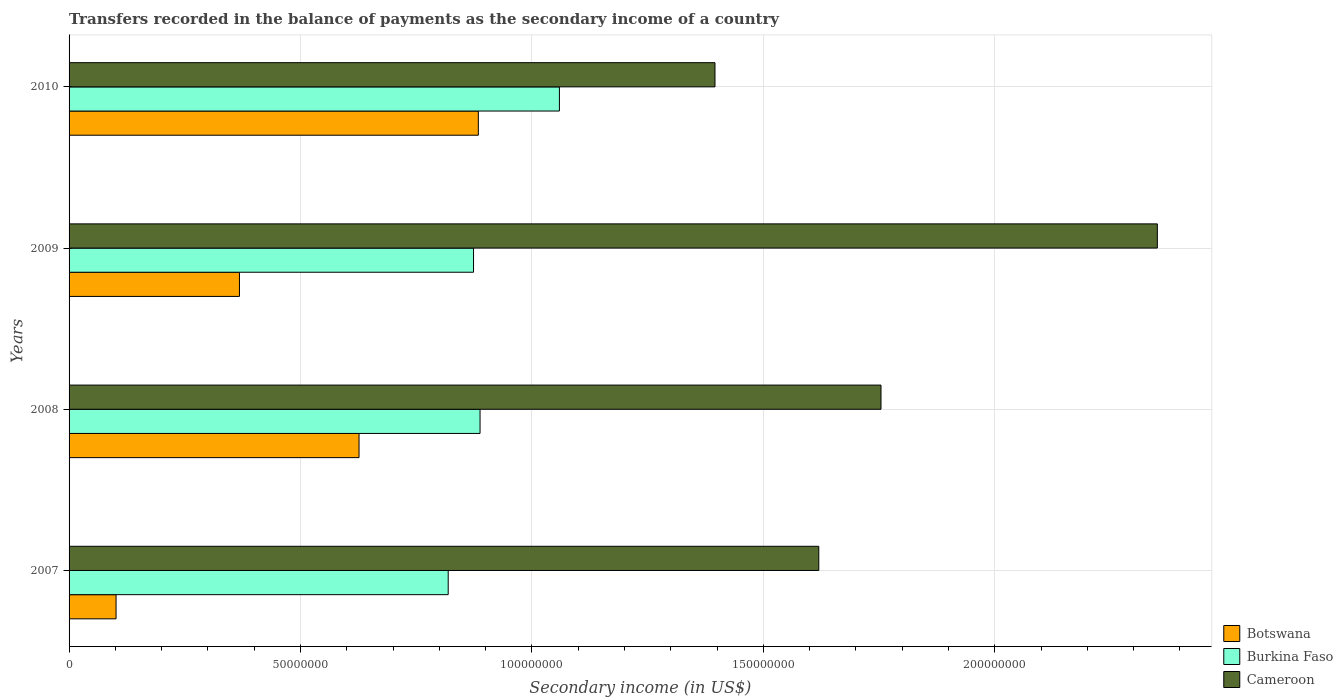Are the number of bars per tick equal to the number of legend labels?
Offer a terse response. Yes. How many bars are there on the 1st tick from the top?
Offer a very short reply. 3. How many bars are there on the 1st tick from the bottom?
Your answer should be compact. 3. What is the secondary income of in Botswana in 2009?
Ensure brevity in your answer.  3.68e+07. Across all years, what is the maximum secondary income of in Burkina Faso?
Ensure brevity in your answer.  1.06e+08. Across all years, what is the minimum secondary income of in Cameroon?
Your answer should be compact. 1.40e+08. In which year was the secondary income of in Cameroon minimum?
Your answer should be very brief. 2010. What is the total secondary income of in Burkina Faso in the graph?
Provide a short and direct response. 3.64e+08. What is the difference between the secondary income of in Botswana in 2008 and that in 2009?
Provide a short and direct response. 2.58e+07. What is the difference between the secondary income of in Botswana in 2010 and the secondary income of in Cameroon in 2007?
Make the answer very short. -7.36e+07. What is the average secondary income of in Botswana per year?
Provide a succinct answer. 4.95e+07. In the year 2008, what is the difference between the secondary income of in Burkina Faso and secondary income of in Botswana?
Offer a terse response. 2.61e+07. What is the ratio of the secondary income of in Botswana in 2007 to that in 2008?
Ensure brevity in your answer.  0.16. Is the difference between the secondary income of in Burkina Faso in 2007 and 2010 greater than the difference between the secondary income of in Botswana in 2007 and 2010?
Keep it short and to the point. Yes. What is the difference between the highest and the second highest secondary income of in Cameroon?
Provide a short and direct response. 5.97e+07. What is the difference between the highest and the lowest secondary income of in Botswana?
Ensure brevity in your answer.  7.83e+07. In how many years, is the secondary income of in Burkina Faso greater than the average secondary income of in Burkina Faso taken over all years?
Offer a terse response. 1. What does the 2nd bar from the top in 2008 represents?
Your response must be concise. Burkina Faso. What does the 2nd bar from the bottom in 2007 represents?
Your answer should be very brief. Burkina Faso. How many bars are there?
Give a very brief answer. 12. Are all the bars in the graph horizontal?
Give a very brief answer. Yes. How many years are there in the graph?
Ensure brevity in your answer.  4. What is the difference between two consecutive major ticks on the X-axis?
Provide a succinct answer. 5.00e+07. Are the values on the major ticks of X-axis written in scientific E-notation?
Offer a terse response. No. Does the graph contain any zero values?
Provide a short and direct response. No. Does the graph contain grids?
Offer a terse response. Yes. Where does the legend appear in the graph?
Ensure brevity in your answer.  Bottom right. What is the title of the graph?
Make the answer very short. Transfers recorded in the balance of payments as the secondary income of a country. What is the label or title of the X-axis?
Your answer should be very brief. Secondary income (in US$). What is the label or title of the Y-axis?
Offer a very short reply. Years. What is the Secondary income (in US$) of Botswana in 2007?
Keep it short and to the point. 1.02e+07. What is the Secondary income (in US$) of Burkina Faso in 2007?
Keep it short and to the point. 8.19e+07. What is the Secondary income (in US$) in Cameroon in 2007?
Your response must be concise. 1.62e+08. What is the Secondary income (in US$) of Botswana in 2008?
Give a very brief answer. 6.26e+07. What is the Secondary income (in US$) in Burkina Faso in 2008?
Your answer should be very brief. 8.88e+07. What is the Secondary income (in US$) of Cameroon in 2008?
Ensure brevity in your answer.  1.75e+08. What is the Secondary income (in US$) in Botswana in 2009?
Your response must be concise. 3.68e+07. What is the Secondary income (in US$) in Burkina Faso in 2009?
Offer a very short reply. 8.74e+07. What is the Secondary income (in US$) in Cameroon in 2009?
Your answer should be compact. 2.35e+08. What is the Secondary income (in US$) in Botswana in 2010?
Give a very brief answer. 8.84e+07. What is the Secondary income (in US$) of Burkina Faso in 2010?
Ensure brevity in your answer.  1.06e+08. What is the Secondary income (in US$) of Cameroon in 2010?
Offer a very short reply. 1.40e+08. Across all years, what is the maximum Secondary income (in US$) in Botswana?
Provide a succinct answer. 8.84e+07. Across all years, what is the maximum Secondary income (in US$) in Burkina Faso?
Offer a very short reply. 1.06e+08. Across all years, what is the maximum Secondary income (in US$) of Cameroon?
Make the answer very short. 2.35e+08. Across all years, what is the minimum Secondary income (in US$) of Botswana?
Your response must be concise. 1.02e+07. Across all years, what is the minimum Secondary income (in US$) of Burkina Faso?
Give a very brief answer. 8.19e+07. Across all years, what is the minimum Secondary income (in US$) in Cameroon?
Ensure brevity in your answer.  1.40e+08. What is the total Secondary income (in US$) of Botswana in the graph?
Offer a terse response. 1.98e+08. What is the total Secondary income (in US$) in Burkina Faso in the graph?
Provide a short and direct response. 3.64e+08. What is the total Secondary income (in US$) of Cameroon in the graph?
Make the answer very short. 7.12e+08. What is the difference between the Secondary income (in US$) in Botswana in 2007 and that in 2008?
Your answer should be very brief. -5.25e+07. What is the difference between the Secondary income (in US$) of Burkina Faso in 2007 and that in 2008?
Offer a terse response. -6.88e+06. What is the difference between the Secondary income (in US$) of Cameroon in 2007 and that in 2008?
Your answer should be very brief. -1.34e+07. What is the difference between the Secondary income (in US$) in Botswana in 2007 and that in 2009?
Your answer should be very brief. -2.67e+07. What is the difference between the Secondary income (in US$) in Burkina Faso in 2007 and that in 2009?
Ensure brevity in your answer.  -5.47e+06. What is the difference between the Secondary income (in US$) in Cameroon in 2007 and that in 2009?
Provide a succinct answer. -7.31e+07. What is the difference between the Secondary income (in US$) in Botswana in 2007 and that in 2010?
Your answer should be very brief. -7.83e+07. What is the difference between the Secondary income (in US$) of Burkina Faso in 2007 and that in 2010?
Your response must be concise. -2.40e+07. What is the difference between the Secondary income (in US$) in Cameroon in 2007 and that in 2010?
Give a very brief answer. 2.24e+07. What is the difference between the Secondary income (in US$) of Botswana in 2008 and that in 2009?
Keep it short and to the point. 2.58e+07. What is the difference between the Secondary income (in US$) in Burkina Faso in 2008 and that in 2009?
Give a very brief answer. 1.41e+06. What is the difference between the Secondary income (in US$) of Cameroon in 2008 and that in 2009?
Ensure brevity in your answer.  -5.97e+07. What is the difference between the Secondary income (in US$) in Botswana in 2008 and that in 2010?
Your answer should be compact. -2.58e+07. What is the difference between the Secondary income (in US$) of Burkina Faso in 2008 and that in 2010?
Offer a very short reply. -1.71e+07. What is the difference between the Secondary income (in US$) in Cameroon in 2008 and that in 2010?
Give a very brief answer. 3.59e+07. What is the difference between the Secondary income (in US$) in Botswana in 2009 and that in 2010?
Your answer should be very brief. -5.16e+07. What is the difference between the Secondary income (in US$) in Burkina Faso in 2009 and that in 2010?
Your answer should be compact. -1.86e+07. What is the difference between the Secondary income (in US$) in Cameroon in 2009 and that in 2010?
Your answer should be very brief. 9.56e+07. What is the difference between the Secondary income (in US$) of Botswana in 2007 and the Secondary income (in US$) of Burkina Faso in 2008?
Offer a terse response. -7.86e+07. What is the difference between the Secondary income (in US$) in Botswana in 2007 and the Secondary income (in US$) in Cameroon in 2008?
Offer a very short reply. -1.65e+08. What is the difference between the Secondary income (in US$) in Burkina Faso in 2007 and the Secondary income (in US$) in Cameroon in 2008?
Your response must be concise. -9.35e+07. What is the difference between the Secondary income (in US$) of Botswana in 2007 and the Secondary income (in US$) of Burkina Faso in 2009?
Ensure brevity in your answer.  -7.72e+07. What is the difference between the Secondary income (in US$) of Botswana in 2007 and the Secondary income (in US$) of Cameroon in 2009?
Keep it short and to the point. -2.25e+08. What is the difference between the Secondary income (in US$) in Burkina Faso in 2007 and the Secondary income (in US$) in Cameroon in 2009?
Your answer should be very brief. -1.53e+08. What is the difference between the Secondary income (in US$) of Botswana in 2007 and the Secondary income (in US$) of Burkina Faso in 2010?
Provide a succinct answer. -9.58e+07. What is the difference between the Secondary income (in US$) of Botswana in 2007 and the Secondary income (in US$) of Cameroon in 2010?
Ensure brevity in your answer.  -1.29e+08. What is the difference between the Secondary income (in US$) in Burkina Faso in 2007 and the Secondary income (in US$) in Cameroon in 2010?
Offer a terse response. -5.76e+07. What is the difference between the Secondary income (in US$) of Botswana in 2008 and the Secondary income (in US$) of Burkina Faso in 2009?
Provide a short and direct response. -2.47e+07. What is the difference between the Secondary income (in US$) in Botswana in 2008 and the Secondary income (in US$) in Cameroon in 2009?
Offer a terse response. -1.72e+08. What is the difference between the Secondary income (in US$) in Burkina Faso in 2008 and the Secondary income (in US$) in Cameroon in 2009?
Provide a short and direct response. -1.46e+08. What is the difference between the Secondary income (in US$) of Botswana in 2008 and the Secondary income (in US$) of Burkina Faso in 2010?
Your answer should be compact. -4.33e+07. What is the difference between the Secondary income (in US$) of Botswana in 2008 and the Secondary income (in US$) of Cameroon in 2010?
Give a very brief answer. -7.69e+07. What is the difference between the Secondary income (in US$) in Burkina Faso in 2008 and the Secondary income (in US$) in Cameroon in 2010?
Offer a terse response. -5.08e+07. What is the difference between the Secondary income (in US$) of Botswana in 2009 and the Secondary income (in US$) of Burkina Faso in 2010?
Your answer should be very brief. -6.91e+07. What is the difference between the Secondary income (in US$) in Botswana in 2009 and the Secondary income (in US$) in Cameroon in 2010?
Keep it short and to the point. -1.03e+08. What is the difference between the Secondary income (in US$) of Burkina Faso in 2009 and the Secondary income (in US$) of Cameroon in 2010?
Your answer should be very brief. -5.22e+07. What is the average Secondary income (in US$) of Botswana per year?
Your answer should be compact. 4.95e+07. What is the average Secondary income (in US$) of Burkina Faso per year?
Ensure brevity in your answer.  9.10e+07. What is the average Secondary income (in US$) of Cameroon per year?
Give a very brief answer. 1.78e+08. In the year 2007, what is the difference between the Secondary income (in US$) in Botswana and Secondary income (in US$) in Burkina Faso?
Your answer should be compact. -7.18e+07. In the year 2007, what is the difference between the Secondary income (in US$) in Botswana and Secondary income (in US$) in Cameroon?
Offer a very short reply. -1.52e+08. In the year 2007, what is the difference between the Secondary income (in US$) of Burkina Faso and Secondary income (in US$) of Cameroon?
Offer a very short reply. -8.01e+07. In the year 2008, what is the difference between the Secondary income (in US$) of Botswana and Secondary income (in US$) of Burkina Faso?
Your answer should be compact. -2.61e+07. In the year 2008, what is the difference between the Secondary income (in US$) in Botswana and Secondary income (in US$) in Cameroon?
Offer a terse response. -1.13e+08. In the year 2008, what is the difference between the Secondary income (in US$) of Burkina Faso and Secondary income (in US$) of Cameroon?
Ensure brevity in your answer.  -8.66e+07. In the year 2009, what is the difference between the Secondary income (in US$) in Botswana and Secondary income (in US$) in Burkina Faso?
Your answer should be very brief. -5.06e+07. In the year 2009, what is the difference between the Secondary income (in US$) in Botswana and Secondary income (in US$) in Cameroon?
Offer a terse response. -1.98e+08. In the year 2009, what is the difference between the Secondary income (in US$) in Burkina Faso and Secondary income (in US$) in Cameroon?
Make the answer very short. -1.48e+08. In the year 2010, what is the difference between the Secondary income (in US$) of Botswana and Secondary income (in US$) of Burkina Faso?
Make the answer very short. -1.75e+07. In the year 2010, what is the difference between the Secondary income (in US$) of Botswana and Secondary income (in US$) of Cameroon?
Offer a very short reply. -5.11e+07. In the year 2010, what is the difference between the Secondary income (in US$) of Burkina Faso and Secondary income (in US$) of Cameroon?
Make the answer very short. -3.36e+07. What is the ratio of the Secondary income (in US$) in Botswana in 2007 to that in 2008?
Provide a succinct answer. 0.16. What is the ratio of the Secondary income (in US$) of Burkina Faso in 2007 to that in 2008?
Provide a succinct answer. 0.92. What is the ratio of the Secondary income (in US$) in Cameroon in 2007 to that in 2008?
Ensure brevity in your answer.  0.92. What is the ratio of the Secondary income (in US$) in Botswana in 2007 to that in 2009?
Your answer should be very brief. 0.28. What is the ratio of the Secondary income (in US$) in Burkina Faso in 2007 to that in 2009?
Keep it short and to the point. 0.94. What is the ratio of the Secondary income (in US$) of Cameroon in 2007 to that in 2009?
Your answer should be compact. 0.69. What is the ratio of the Secondary income (in US$) of Botswana in 2007 to that in 2010?
Your answer should be very brief. 0.11. What is the ratio of the Secondary income (in US$) in Burkina Faso in 2007 to that in 2010?
Make the answer very short. 0.77. What is the ratio of the Secondary income (in US$) in Cameroon in 2007 to that in 2010?
Give a very brief answer. 1.16. What is the ratio of the Secondary income (in US$) of Botswana in 2008 to that in 2009?
Offer a terse response. 1.7. What is the ratio of the Secondary income (in US$) of Burkina Faso in 2008 to that in 2009?
Ensure brevity in your answer.  1.02. What is the ratio of the Secondary income (in US$) in Cameroon in 2008 to that in 2009?
Keep it short and to the point. 0.75. What is the ratio of the Secondary income (in US$) of Botswana in 2008 to that in 2010?
Offer a terse response. 0.71. What is the ratio of the Secondary income (in US$) in Burkina Faso in 2008 to that in 2010?
Provide a succinct answer. 0.84. What is the ratio of the Secondary income (in US$) in Cameroon in 2008 to that in 2010?
Provide a succinct answer. 1.26. What is the ratio of the Secondary income (in US$) in Botswana in 2009 to that in 2010?
Offer a terse response. 0.42. What is the ratio of the Secondary income (in US$) in Burkina Faso in 2009 to that in 2010?
Provide a short and direct response. 0.82. What is the ratio of the Secondary income (in US$) in Cameroon in 2009 to that in 2010?
Ensure brevity in your answer.  1.68. What is the difference between the highest and the second highest Secondary income (in US$) in Botswana?
Offer a terse response. 2.58e+07. What is the difference between the highest and the second highest Secondary income (in US$) in Burkina Faso?
Offer a very short reply. 1.71e+07. What is the difference between the highest and the second highest Secondary income (in US$) of Cameroon?
Keep it short and to the point. 5.97e+07. What is the difference between the highest and the lowest Secondary income (in US$) in Botswana?
Give a very brief answer. 7.83e+07. What is the difference between the highest and the lowest Secondary income (in US$) of Burkina Faso?
Give a very brief answer. 2.40e+07. What is the difference between the highest and the lowest Secondary income (in US$) of Cameroon?
Keep it short and to the point. 9.56e+07. 